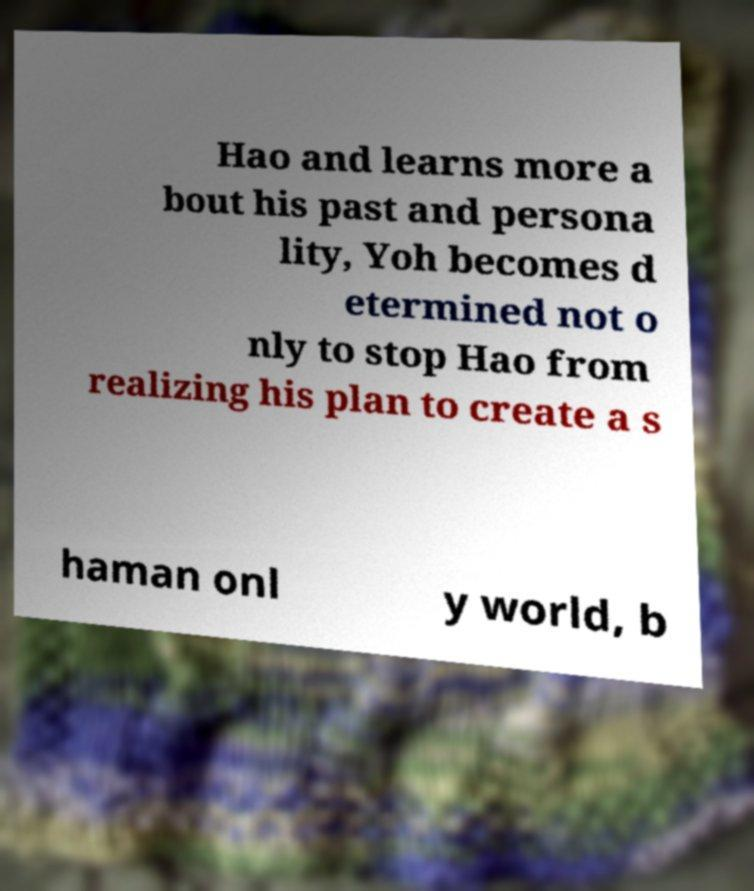What messages or text are displayed in this image? I need them in a readable, typed format. Hao and learns more a bout his past and persona lity, Yoh becomes d etermined not o nly to stop Hao from realizing his plan to create a s haman onl y world, b 